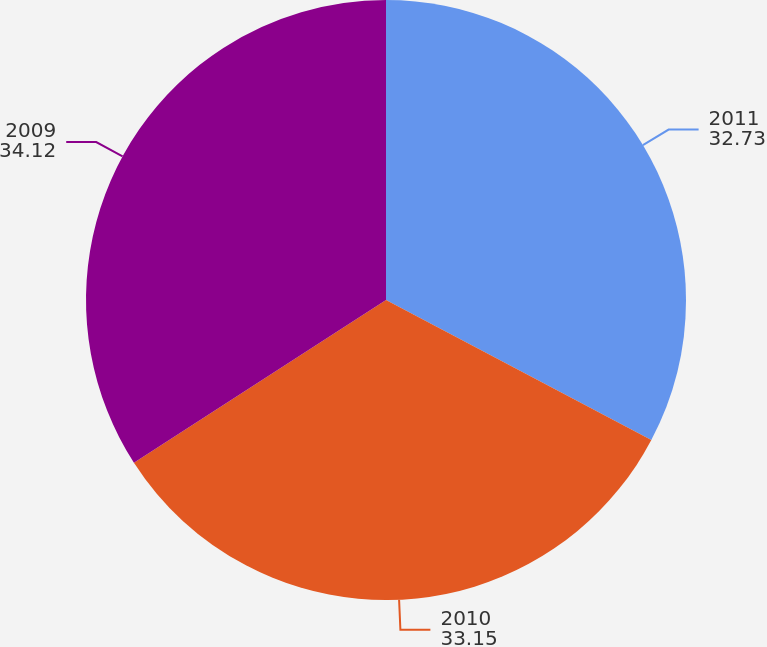Convert chart to OTSL. <chart><loc_0><loc_0><loc_500><loc_500><pie_chart><fcel>2011<fcel>2010<fcel>2009<nl><fcel>32.73%<fcel>33.15%<fcel>34.12%<nl></chart> 